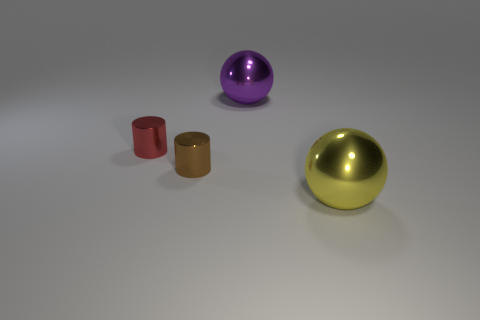There is a cylinder in front of the red object; what is it made of?
Ensure brevity in your answer.  Metal. Does the big thing that is right of the big purple sphere have the same shape as the big thing that is behind the small brown metallic thing?
Provide a short and direct response. Yes. Are there any brown metallic cylinders?
Keep it short and to the point. Yes. There is a yellow object that is the same shape as the purple metallic object; what material is it?
Give a very brief answer. Metal. Are there any metallic balls behind the tiny red object?
Offer a terse response. Yes. What is the shape of the red object?
Offer a terse response. Cylinder. There is a big sphere that is behind the big sphere in front of the purple shiny object; what color is it?
Ensure brevity in your answer.  Purple. What size is the brown cylinder that is behind the big yellow metallic object?
Ensure brevity in your answer.  Small. Is there a gray ball that has the same material as the big yellow object?
Your response must be concise. No. How many other large metallic things are the same shape as the yellow object?
Your answer should be very brief. 1. 